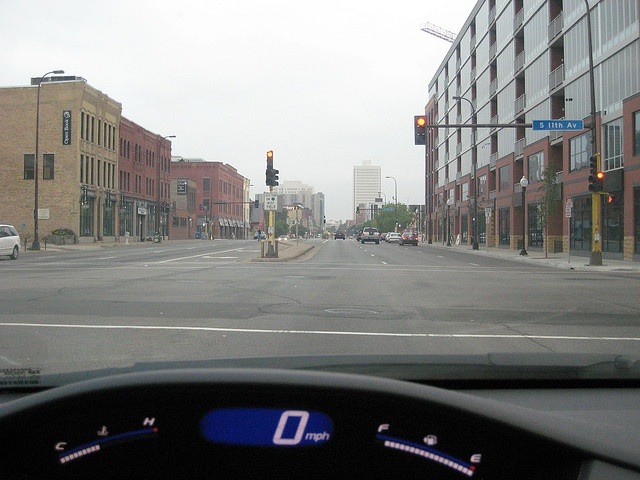Describe the objects in this image and their specific colors. I can see car in white, black, and gray tones, car in white, darkgray, gray, lightgray, and purple tones, traffic light in white, gray, khaki, and lightgray tones, traffic light in white, black, maroon, gray, and darkgreen tones, and truck in white, gray, darkgray, purple, and black tones in this image. 